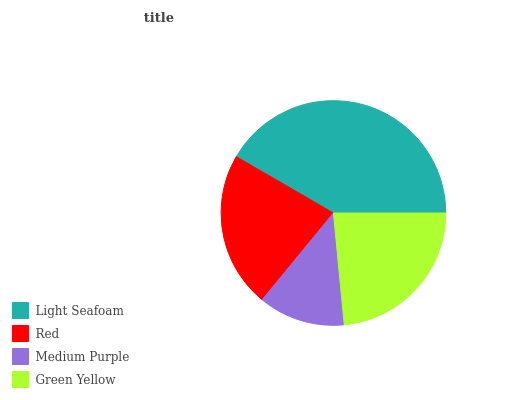Is Medium Purple the minimum?
Answer yes or no. Yes. Is Light Seafoam the maximum?
Answer yes or no. Yes. Is Red the minimum?
Answer yes or no. No. Is Red the maximum?
Answer yes or no. No. Is Light Seafoam greater than Red?
Answer yes or no. Yes. Is Red less than Light Seafoam?
Answer yes or no. Yes. Is Red greater than Light Seafoam?
Answer yes or no. No. Is Light Seafoam less than Red?
Answer yes or no. No. Is Green Yellow the high median?
Answer yes or no. Yes. Is Red the low median?
Answer yes or no. Yes. Is Red the high median?
Answer yes or no. No. Is Medium Purple the low median?
Answer yes or no. No. 